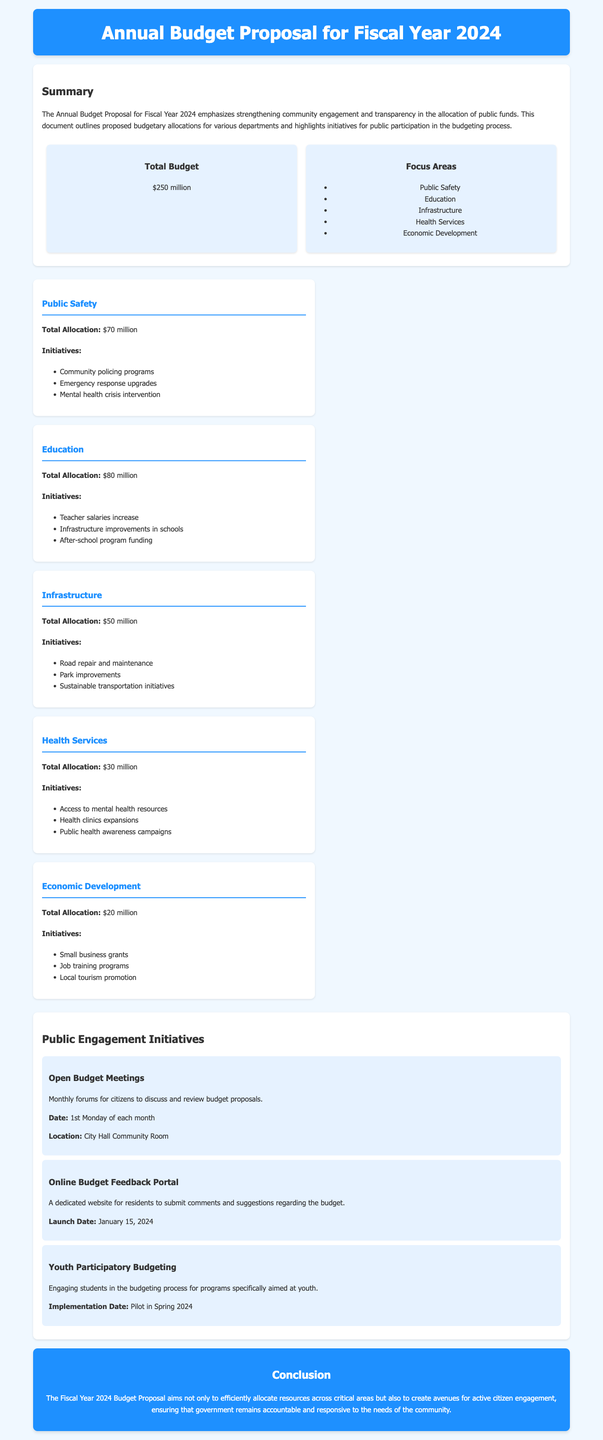what is the total budget proposed for FY 2024? The total budget is stated in the summary section of the document as $250 million.
Answer: $250 million how much is allocated to Education? The document specifies that the total allocation for Education is found in the departments section.
Answer: $80 million what initiative is related to Public Safety? The document lists initiatives under each department; one for Public Safety is "Community policing programs."
Answer: Community policing programs when are the Open Budget Meetings held? The Open Budget Meetings' date is mentioned in the public engagement section of the document.
Answer: 1st Monday of each month what is the launch date for the Online Budget Feedback Portal? The launch date for this initiative is explicitly provided in the public engagement initiatives section.
Answer: January 15, 2024 which department has the least budget allocation? The department allocations are provided in the departments section, identifying the one with the smallest amount.
Answer: Economic Development what is the focus area of the budget related to infrastructure? The summary section lists focus areas, including Infrastructure.
Answer: Infrastructure what type of engagement initiative is aimed at students? The document describes programs aimed specifically at youth, which is part of the public engagement initiatives.
Answer: Youth Participatory Budgeting 